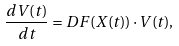<formula> <loc_0><loc_0><loc_500><loc_500>\frac { d V ( t ) } { d t } = D F ( X ( t ) ) \cdot V ( t ) ,</formula> 